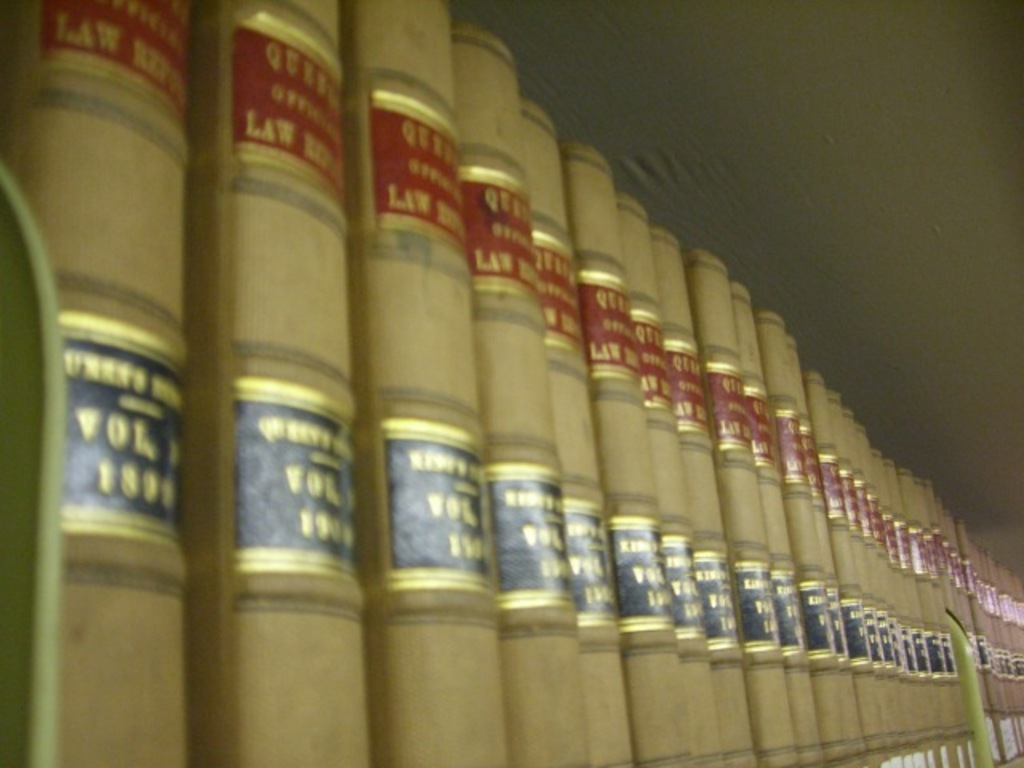Provide a one-sentence caption for the provided image.
Reference OCR token: LAW, QUTY, LAT, TH, FHIE, PY Tan with red and black Law books are lined up on a shelf. 